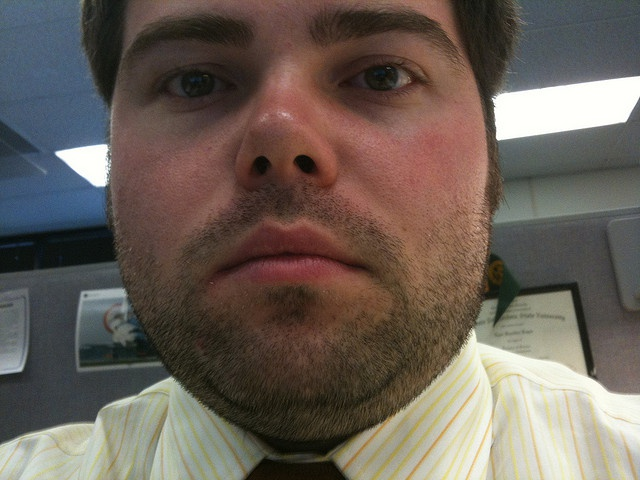Describe the objects in this image and their specific colors. I can see people in gray, black, maroon, and brown tones and tie in black and gray tones in this image. 